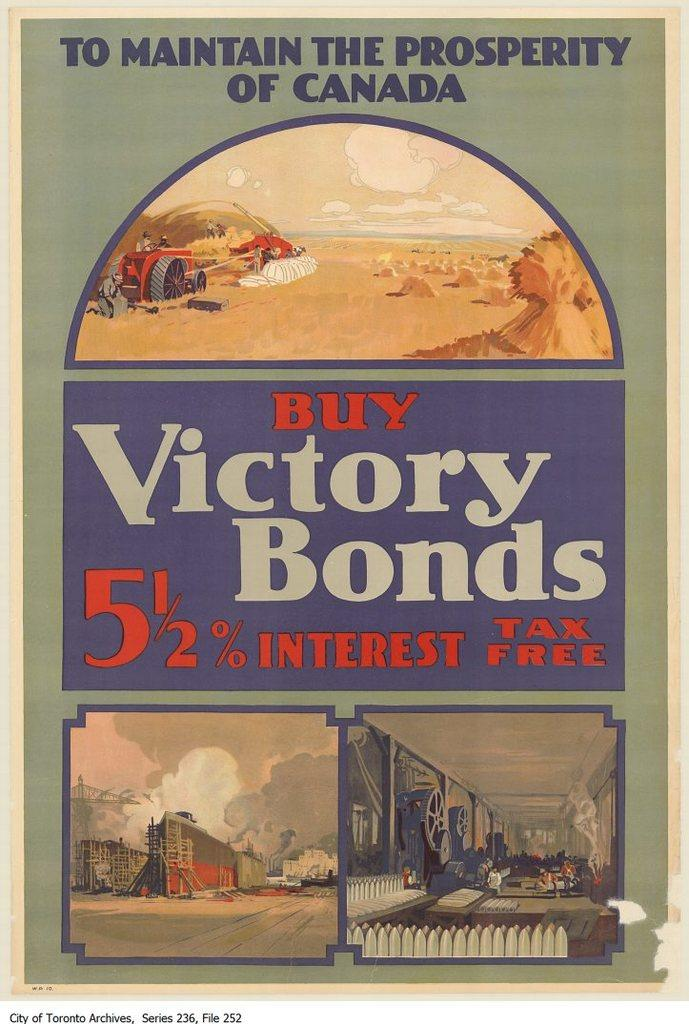<image>
Render a clear and concise summary of the photo. The Victory Bonds have a 5.5% interest rate. 